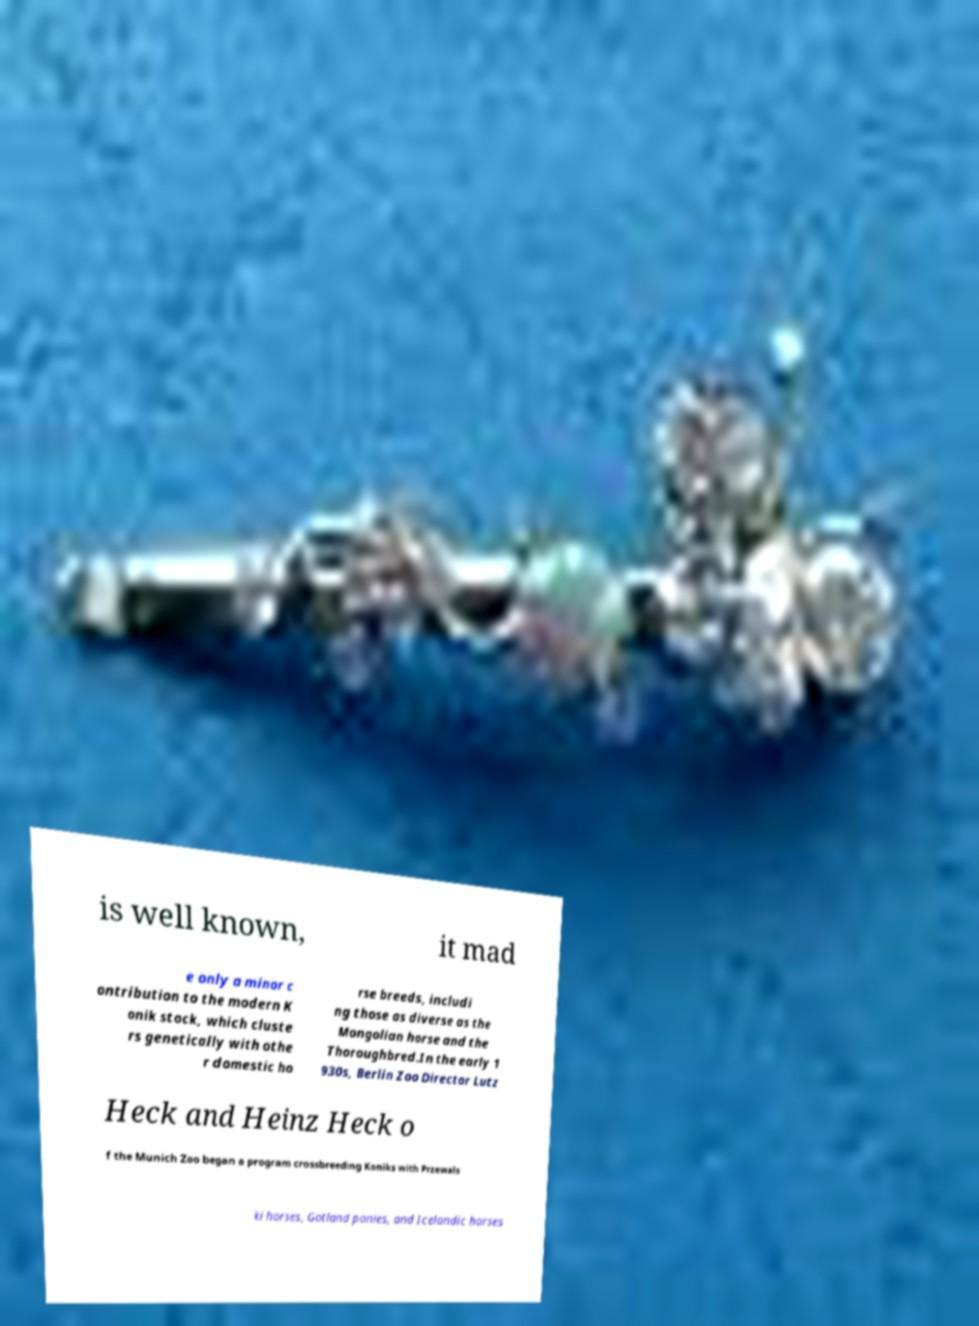Can you read and provide the text displayed in the image?This photo seems to have some interesting text. Can you extract and type it out for me? is well known, it mad e only a minor c ontribution to the modern K onik stock, which cluste rs genetically with othe r domestic ho rse breeds, includi ng those as diverse as the Mongolian horse and the Thoroughbred.In the early 1 930s, Berlin Zoo Director Lutz Heck and Heinz Heck o f the Munich Zoo began a program crossbreeding Koniks with Przewals ki horses, Gotland ponies, and Icelandic horses 